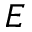<formula> <loc_0><loc_0><loc_500><loc_500>E</formula> 